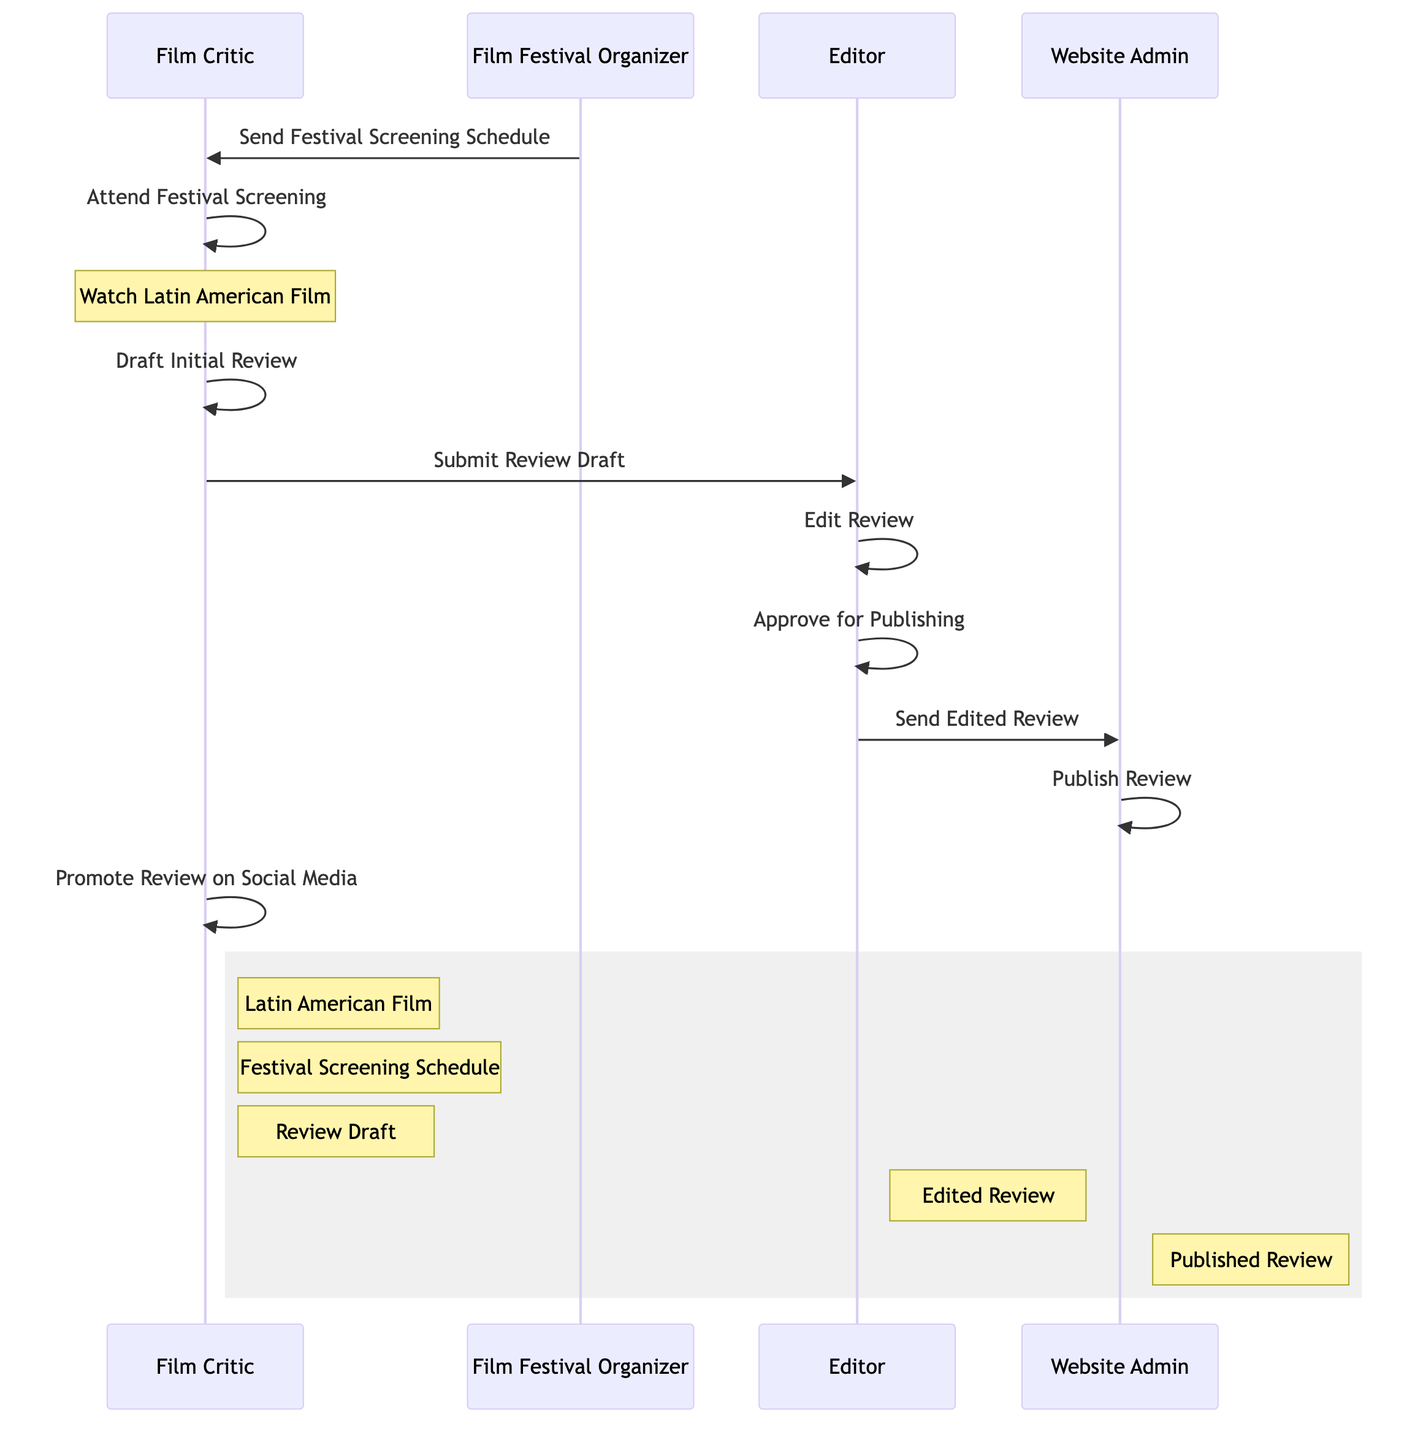What is the first action taken by the Film Critic? According to the sequence diagram, the first action taken by the Film Critic is "Receive Screening Schedule". This is the initial action before any festival activities or review processes begin.
Answer: Receive Screening Schedule How many actors are involved in the process? The sequence diagram shows four distinct actors: Film Critic, Film Festival Organizer, Editor, and Website Admin. Counting all of them gives us a total of four actors involved in the process.
Answer: Four What is the last action performed in the sequence? The last action in the diagram is "Publish Review", which is performed by the Website Admin. This indicates the completion of the review process, culminating in the review being made public.
Answer: Publish Review What does the Editor do after receiving the Review Draft? After receiving the Review Draft, the Editor proceeds to "Edit Review". This shows the process in which the review is refined before approval for publishing.
Answer: Edit Review Who promotes the review on social media? The action of promoting the review on social media is explicitly done by the Film Critic, as shown in the last action of the sequence diagram. This indicates their role in sharing the review post-publication.
Answer: Film Critic What object does the Website Admin need to publish the review? The Website Admin requires the "Edited Review" to perform the action of publishing the review. This shows a dependency on the edited content before it is made public.
Answer: Edited Review How many total actions are included in the sequence? The total actions in the sequence, including all tasks performed by the actors, add up to eight. Counting these actions illustrates the operational flow from receiving the schedule to promoting the review.
Answer: Eight What action occurs after the Film Critic drafts the initial review? Following the drafting of the initial review, the next action for the Film Critic is to "Submit Review to Editor". This is a necessary step to move the review into the editing phase.
Answer: Submit Review to Editor What task does the Editor perform before sending the review to the Website Admin? Prior to sending the review to the Website Admin, the Editor must "Approve for Publishing" the edited review. This ensures that the content meets the required standards before publication.
Answer: Approve for Publishing 